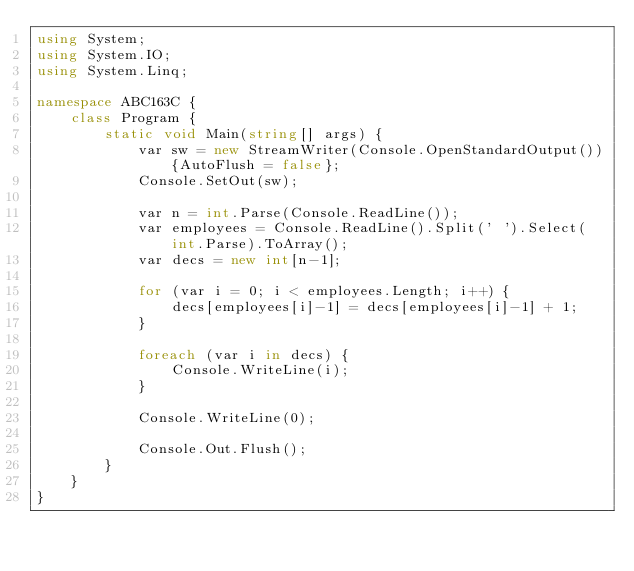Convert code to text. <code><loc_0><loc_0><loc_500><loc_500><_C#_>using System;
using System.IO;
using System.Linq;

namespace ABC163C {
    class Program {
        static void Main(string[] args) {
            var sw = new StreamWriter(Console.OpenStandardOutput()){AutoFlush = false};
            Console.SetOut(sw);

            var n = int.Parse(Console.ReadLine());
            var employees = Console.ReadLine().Split(' ').Select(int.Parse).ToArray();
            var decs = new int[n-1];

            for (var i = 0; i < employees.Length; i++) {
                decs[employees[i]-1] = decs[employees[i]-1] + 1;
            }

            foreach (var i in decs) {
                Console.WriteLine(i);
            }

            Console.WriteLine(0);
            
            Console.Out.Flush();
        }
    }
}</code> 